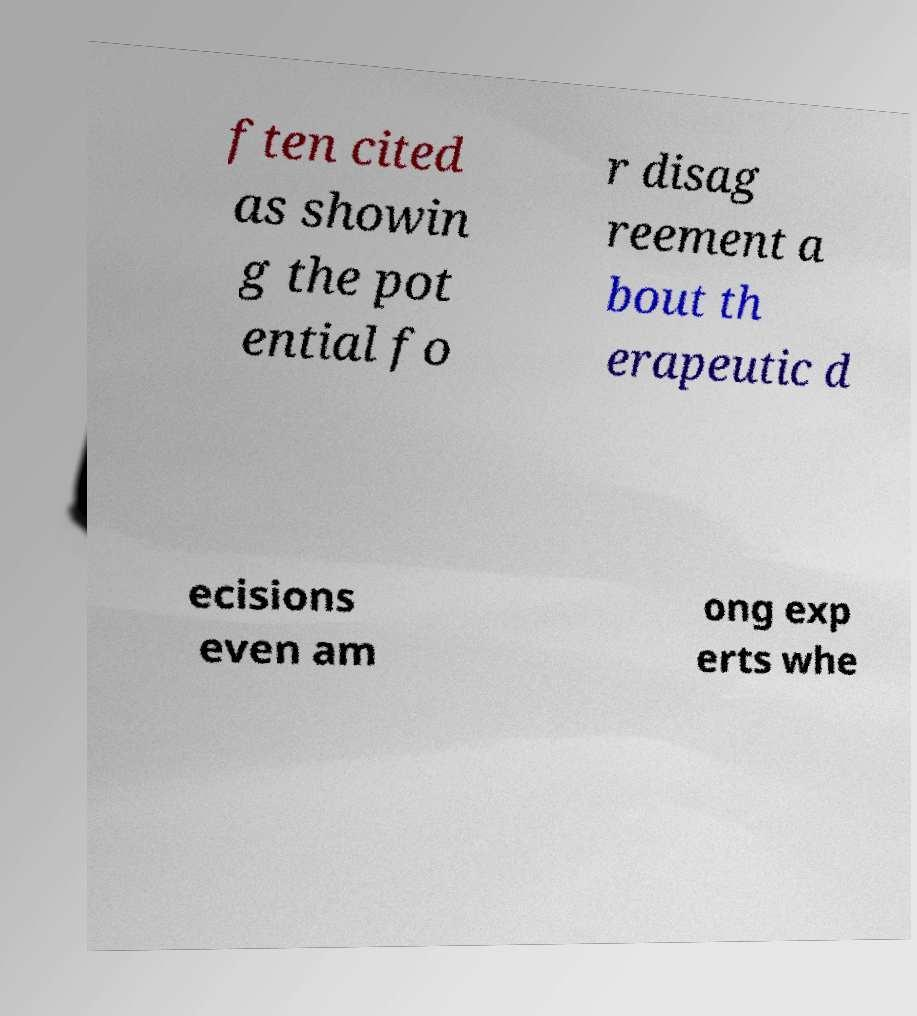There's text embedded in this image that I need extracted. Can you transcribe it verbatim? ften cited as showin g the pot ential fo r disag reement a bout th erapeutic d ecisions even am ong exp erts whe 